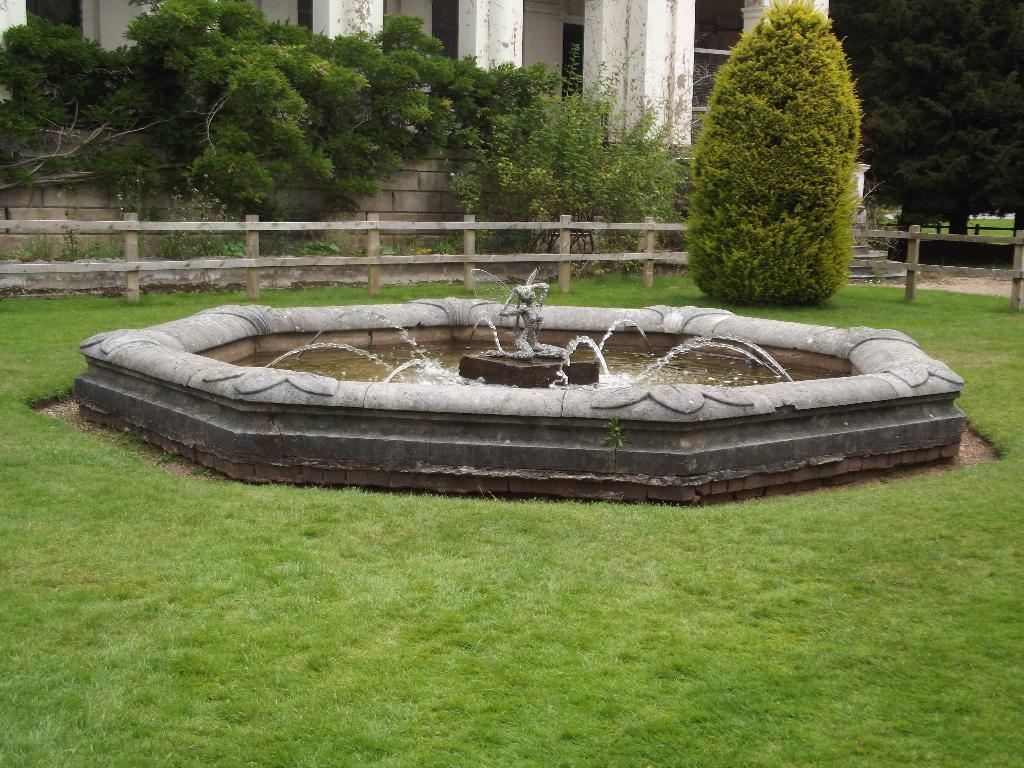Please provide a concise description of this image. In this image there is a fountain, around the fountain there is garden, in the background there is fencing, trees and a building. 